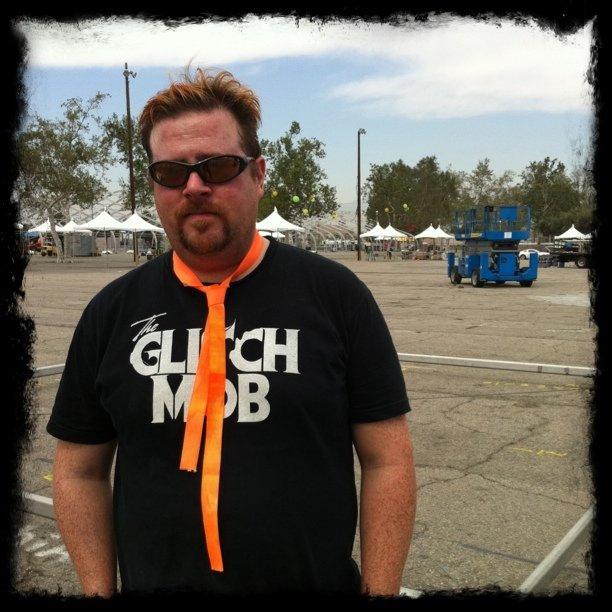What is he wearing around his neck?
Short answer required. Tie. What does his shirt say?
Keep it brief. Glitch mob. What color are the tent tops?
Keep it brief. White. 